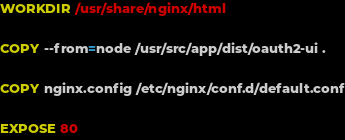Convert code to text. <code><loc_0><loc_0><loc_500><loc_500><_Dockerfile_>
WORKDIR /usr/share/nginx/html

COPY --from=node /usr/src/app/dist/oauth2-ui .

COPY nginx.config /etc/nginx/conf.d/default.conf

EXPOSE 80</code> 